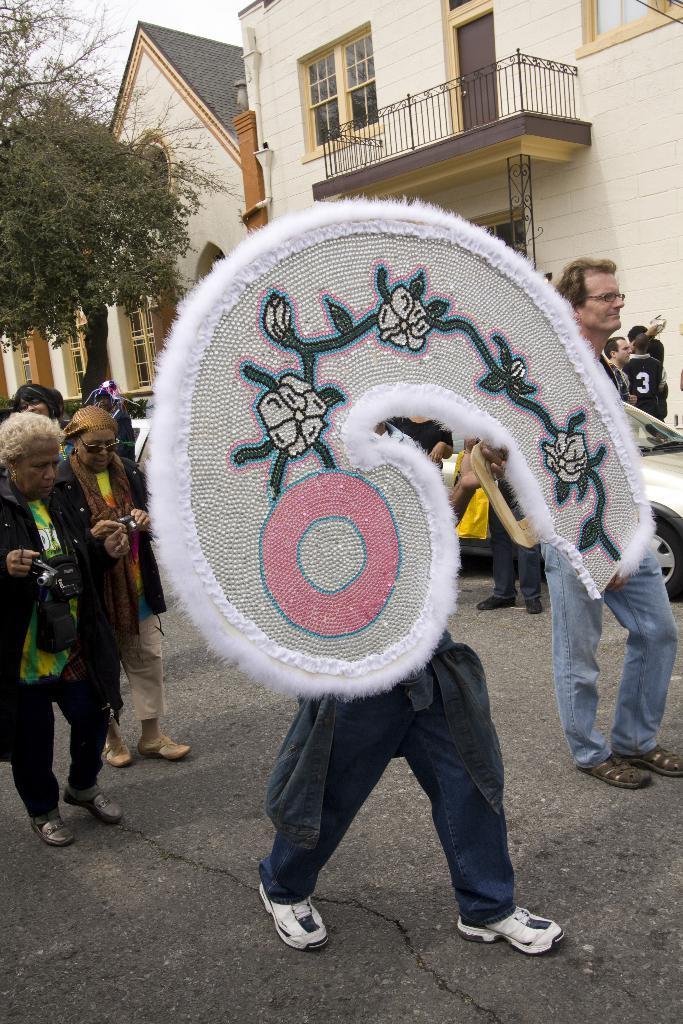In one or two sentences, can you explain what this image depicts? In this picture few people walking and I can see couple of humans holding cameras in their hands and a human holding a board with some design on it and I can see buildings, tree and couple of cars on the road and I can see a cloudy sky. 